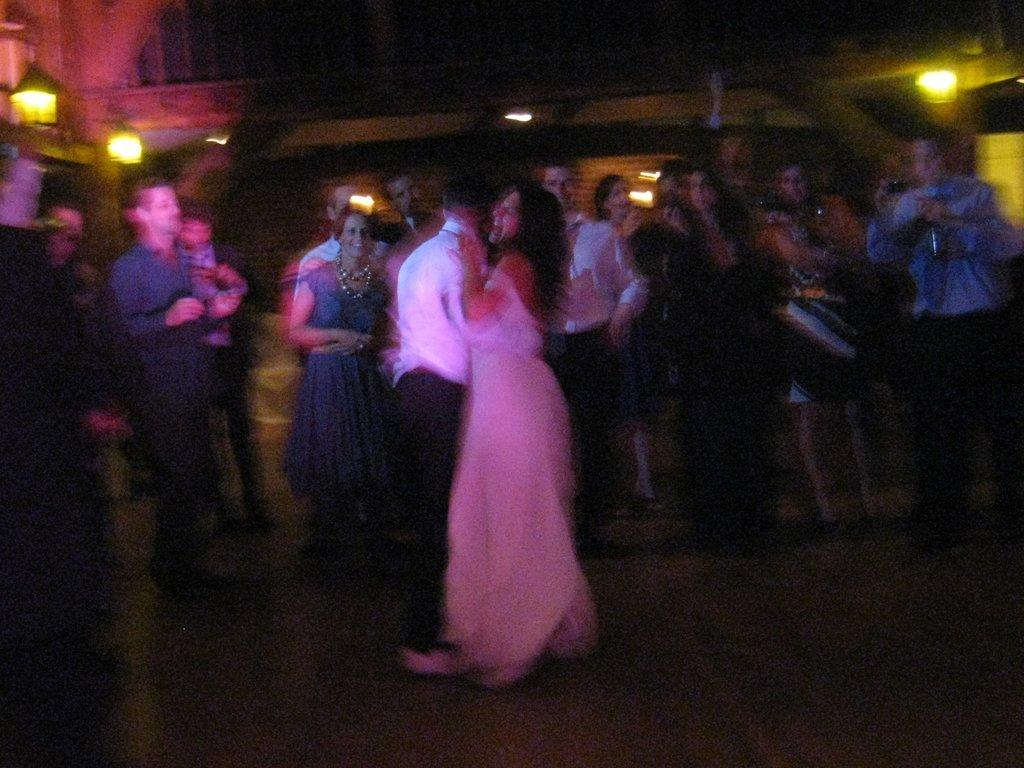What is the overall quality of the image? The image is blurry. Despite the blurriness, can you identify any subjects in the image? There is a group of people standing in the image. Are there any other visual elements present in the image? There are lights visible in the image. What else might be present in the image, even if it's not clear due to the blurriness? There are other objects present in the image. What type of vegetable is being used as a stocking for the window in the image? There is no vegetable being used as a stocking for the window in the image, as there is no window or vegetable present in the image. 